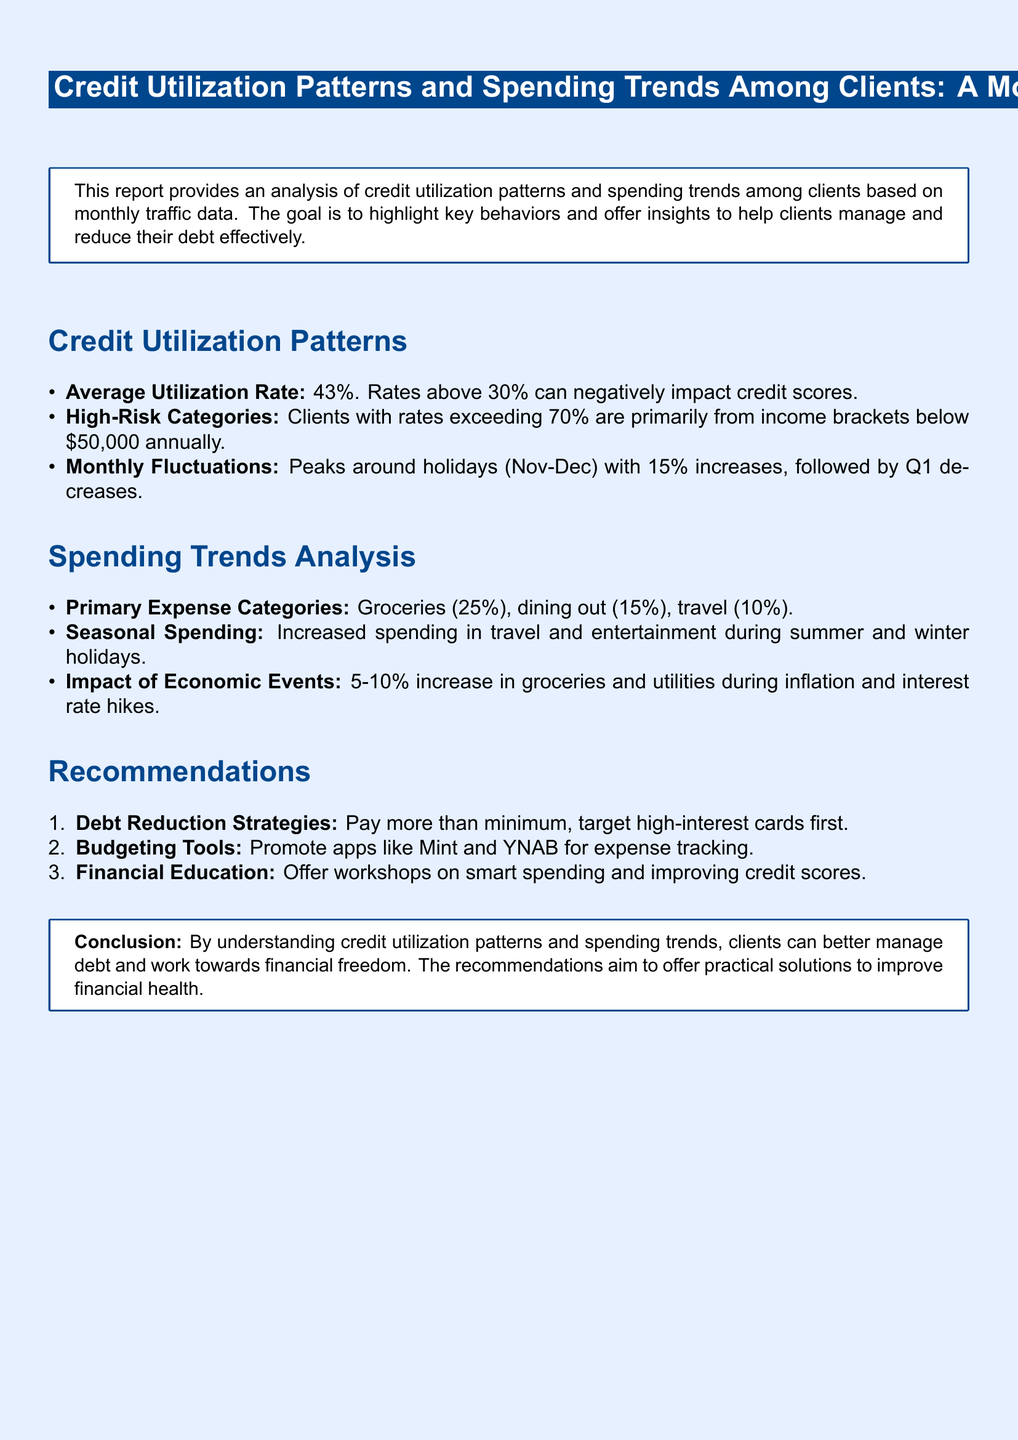What is the average utilization rate? The average utilization rate is stated in the document as 43%.
Answer: 43% What income bracket is primarily associated with high-risk credit utilization? The document mentions that high-risk clients are from income brackets below $50,000 annually.
Answer: Below $50,000 What percentage of clients' spending is on groceries? The document indicates that 25% of spending is allocated to groceries.
Answer: 25% What are the primary expense categories listed in the report? The primary expense categories provided in the document include groceries, dining out, and travel.
Answer: Groceries, dining out, travel What impact do inflation and interest rate hikes have on groceries? According to the document, inflation and interest rate hikes lead to a 5-10% increase in groceries spending.
Answer: 5-10% increase What recommendation is given for debt reduction strategies? The document recommends to pay more than the minimum and target high-interest cards first.
Answer: Pay more than minimum, target high-interest cards first What is highlighted as a seasonal trend in spending? The spending trends indicate increased travel and entertainment spending during summer and winter holidays.
Answer: Increased travel and entertainment during summer and winter holidays What tools are suggested for budgeting? The document suggests promoting apps like Mint and YNAB for expense tracking.
Answer: Mint and YNAB 